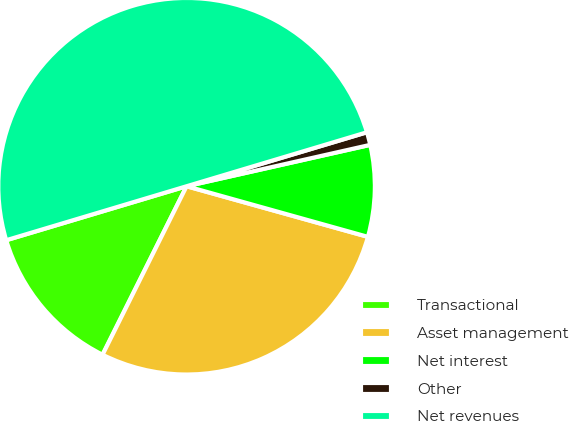Convert chart. <chart><loc_0><loc_0><loc_500><loc_500><pie_chart><fcel>Transactional<fcel>Asset management<fcel>Net interest<fcel>Other<fcel>Net revenues<nl><fcel>13.01%<fcel>28.03%<fcel>7.86%<fcel>1.1%<fcel>50.0%<nl></chart> 